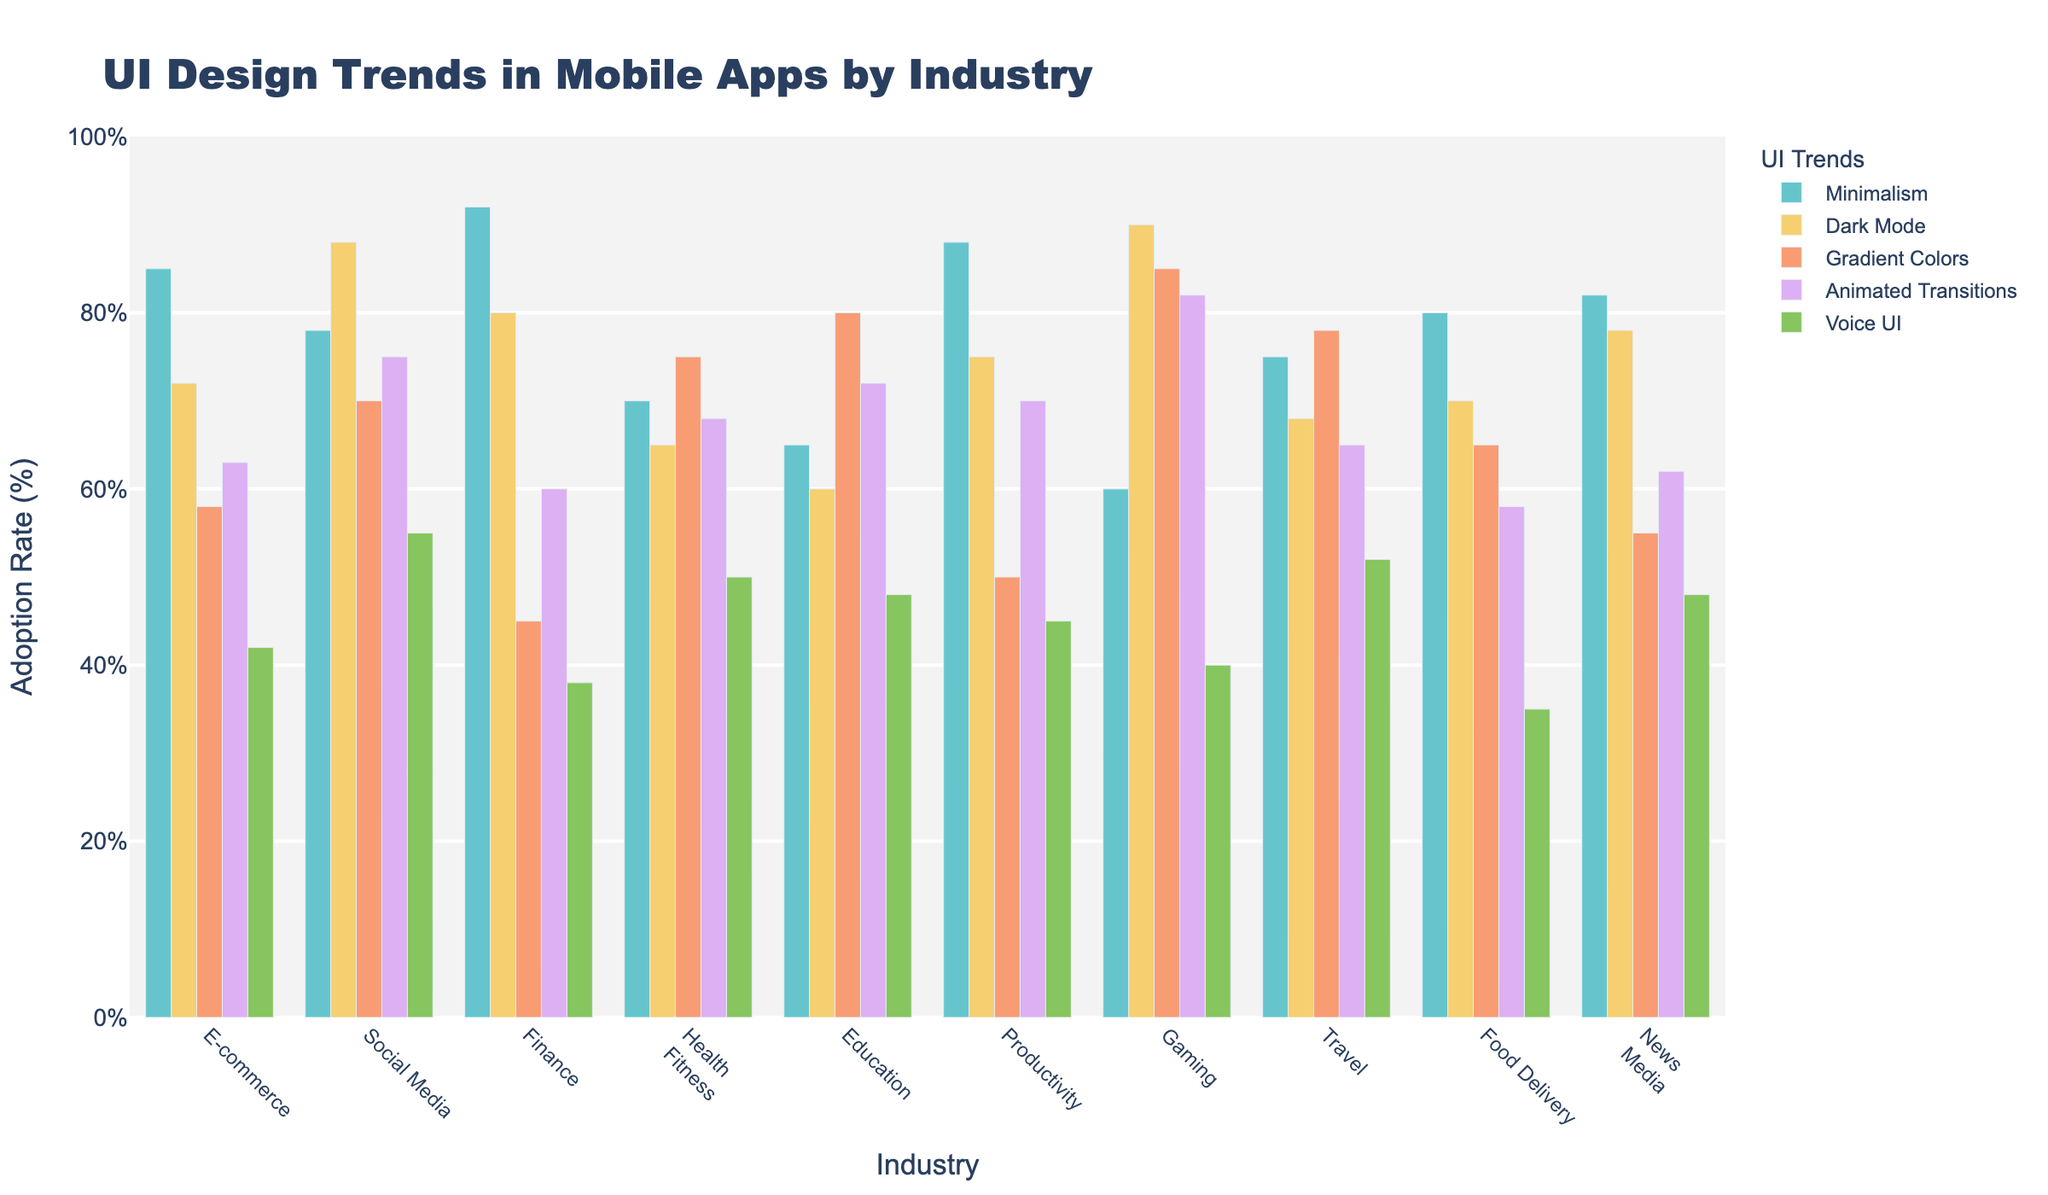What's the most popular UI design trend in the E-commerce industry? The bar for Minimalism in the E-commerce category is the tallest, indicating the highest adoption rate.
Answer: Minimalism Which industry has the lowest adoption rate of Voice UI? The height of the bars representing Voice UI shows that the Food Delivery industry has the shortest bar, corresponding to an adoption rate of 35%.
Answer: Food Delivery How does the adoption rate of Dark Mode in Gaming compare to Social Media? The height of the Dark Mode bar in Gaming (90%) is slightly taller than that in Social Media (88%), indicating a higher adoption rate.
Answer: Gaming What is the difference in adoption rates of Animated Transitions between Health & Fitness and News & Media? The Animated Transitions bar in Health & Fitness is at 68%, while in News & Media, it is at 62%. The difference is 68% - 62% = 6%.
Answer: 6% Which industry shows the highest adoption rate for Gradient Colors? The Education industry has the tallest Gradient Colors bar, indicating the highest adoption rate at 80%.
Answer: Education What is the average adoption rate of Minimalism across all industries? Summing the adoption rates of Minimalism across all industries (85 + 78 + 92 + 70 + 65 + 88 + 60 + 75 + 80 + 82), we get 775. There are ten industries, so the average is 775/10 = 77.5%.
Answer: 77.5% Compare the adoption rates of Animated Transitions in the Finance and Gaming industries. Which one is higher and by how much? The Finance industry's Animated Transitions bar is at 60%, while Gaming's bar is at 82%. The difference is 82% - 60% = 22%. Gaming has a higher rate by 22%.
Answer: Gaming by 22% What are the top two industries for adopting Gradient Colors? The two tallest Gradient Colors bars are in the Gaming (85%) and Education (80%) industries.
Answer: Gaming and Education Which industry has the most balanced adoption rates (least variability) across all trends? By visually inspecting the bars, the Productivity industry has relatively even bar heights for all trends, indicating balanced adoption rates.
Answer: Productivity What is the sum of adoption rates for Voice UI across E-commerce, Health & Fitness, and Travel? The adoption rates for Voice UI are 42% (E-commerce), 50% (Health & Fitness), and 52% (Travel). Summing them gives 42 + 50 + 52 = 144%.
Answer: 144% 